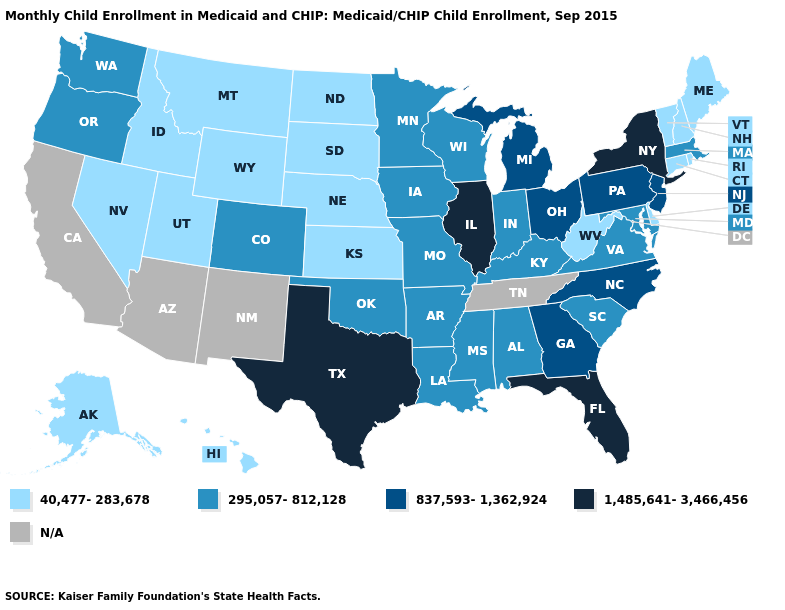Among the states that border Washington , which have the lowest value?
Short answer required. Idaho. Name the states that have a value in the range N/A?
Answer briefly. Arizona, California, New Mexico, Tennessee. Does Connecticut have the lowest value in the Northeast?
Short answer required. Yes. Is the legend a continuous bar?
Answer briefly. No. Name the states that have a value in the range 837,593-1,362,924?
Concise answer only. Georgia, Michigan, New Jersey, North Carolina, Ohio, Pennsylvania. Name the states that have a value in the range 295,057-812,128?
Keep it brief. Alabama, Arkansas, Colorado, Indiana, Iowa, Kentucky, Louisiana, Maryland, Massachusetts, Minnesota, Mississippi, Missouri, Oklahoma, Oregon, South Carolina, Virginia, Washington, Wisconsin. Which states have the lowest value in the USA?
Answer briefly. Alaska, Connecticut, Delaware, Hawaii, Idaho, Kansas, Maine, Montana, Nebraska, Nevada, New Hampshire, North Dakota, Rhode Island, South Dakota, Utah, Vermont, West Virginia, Wyoming. Name the states that have a value in the range 295,057-812,128?
Short answer required. Alabama, Arkansas, Colorado, Indiana, Iowa, Kentucky, Louisiana, Maryland, Massachusetts, Minnesota, Mississippi, Missouri, Oklahoma, Oregon, South Carolina, Virginia, Washington, Wisconsin. Is the legend a continuous bar?
Be succinct. No. Which states have the highest value in the USA?
Keep it brief. Florida, Illinois, New York, Texas. Which states have the lowest value in the South?
Answer briefly. Delaware, West Virginia. Name the states that have a value in the range 295,057-812,128?
Short answer required. Alabama, Arkansas, Colorado, Indiana, Iowa, Kentucky, Louisiana, Maryland, Massachusetts, Minnesota, Mississippi, Missouri, Oklahoma, Oregon, South Carolina, Virginia, Washington, Wisconsin. Which states have the lowest value in the USA?
Give a very brief answer. Alaska, Connecticut, Delaware, Hawaii, Idaho, Kansas, Maine, Montana, Nebraska, Nevada, New Hampshire, North Dakota, Rhode Island, South Dakota, Utah, Vermont, West Virginia, Wyoming. Name the states that have a value in the range 295,057-812,128?
Concise answer only. Alabama, Arkansas, Colorado, Indiana, Iowa, Kentucky, Louisiana, Maryland, Massachusetts, Minnesota, Mississippi, Missouri, Oklahoma, Oregon, South Carolina, Virginia, Washington, Wisconsin. 